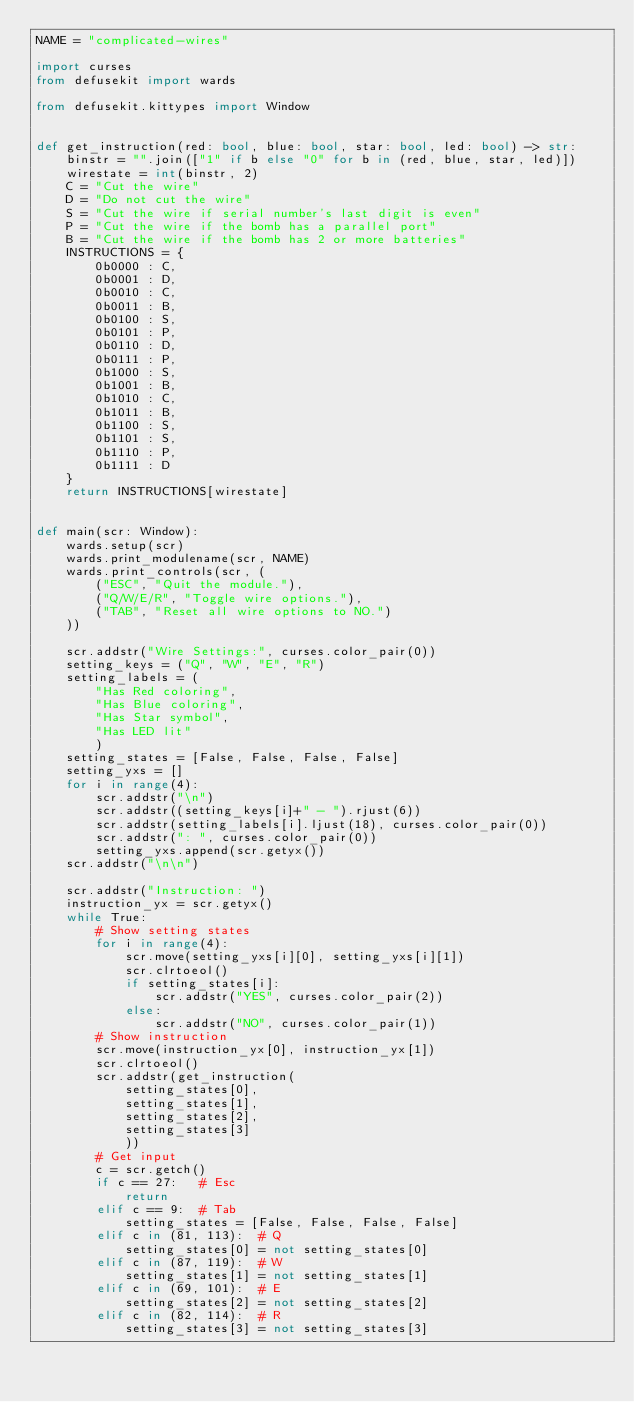<code> <loc_0><loc_0><loc_500><loc_500><_Python_>NAME = "complicated-wires"

import curses
from defusekit import wards

from defusekit.kittypes import Window


def get_instruction(red: bool, blue: bool, star: bool, led: bool) -> str:
    binstr = "".join(["1" if b else "0" for b in (red, blue, star, led)])
    wirestate = int(binstr, 2)
    C = "Cut the wire"
    D = "Do not cut the wire"
    S = "Cut the wire if serial number's last digit is even"
    P = "Cut the wire if the bomb has a parallel port"
    B = "Cut the wire if the bomb has 2 or more batteries"
    INSTRUCTIONS = {
        0b0000 : C,
        0b0001 : D,
        0b0010 : C,
        0b0011 : B,
        0b0100 : S,
        0b0101 : P,
        0b0110 : D,
        0b0111 : P,
        0b1000 : S,
        0b1001 : B,
        0b1010 : C,
        0b1011 : B,
        0b1100 : S,
        0b1101 : S,
        0b1110 : P,
        0b1111 : D
    }
    return INSTRUCTIONS[wirestate]
        

def main(scr: Window):
    wards.setup(scr)
    wards.print_modulename(scr, NAME)
    wards.print_controls(scr, (
        ("ESC", "Quit the module."),
        ("Q/W/E/R", "Toggle wire options."),
        ("TAB", "Reset all wire options to NO.")
    ))

    scr.addstr("Wire Settings:", curses.color_pair(0))
    setting_keys = ("Q", "W", "E", "R")
    setting_labels = (
        "Has Red coloring",
        "Has Blue coloring",
        "Has Star symbol",
        "Has LED lit"
        )
    setting_states = [False, False, False, False]
    setting_yxs = []
    for i in range(4):
        scr.addstr("\n")
        scr.addstr((setting_keys[i]+" - ").rjust(6))
        scr.addstr(setting_labels[i].ljust(18), curses.color_pair(0))
        scr.addstr(": ", curses.color_pair(0))
        setting_yxs.append(scr.getyx())
    scr.addstr("\n\n")

    scr.addstr("Instruction: ")
    instruction_yx = scr.getyx()
    while True:
        # Show setting states
        for i in range(4):
            scr.move(setting_yxs[i][0], setting_yxs[i][1])
            scr.clrtoeol()
            if setting_states[i]:
                scr.addstr("YES", curses.color_pair(2))
            else:
                scr.addstr("NO", curses.color_pair(1))
        # Show instruction
        scr.move(instruction_yx[0], instruction_yx[1])
        scr.clrtoeol()
        scr.addstr(get_instruction(
            setting_states[0],
            setting_states[1],
            setting_states[2],
            setting_states[3]
            ))
        # Get input
        c = scr.getch()
        if c == 27:   # Esc
            return
        elif c == 9:  # Tab
            setting_states = [False, False, False, False]
        elif c in (81, 113):  # Q
            setting_states[0] = not setting_states[0]
        elif c in (87, 119):  # W
            setting_states[1] = not setting_states[1]
        elif c in (69, 101):  # E
            setting_states[2] = not setting_states[2]
        elif c in (82, 114):  # R
            setting_states[3] = not setting_states[3]
</code> 